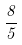Convert formula to latex. <formula><loc_0><loc_0><loc_500><loc_500>\frac { 8 } { 5 }</formula> 